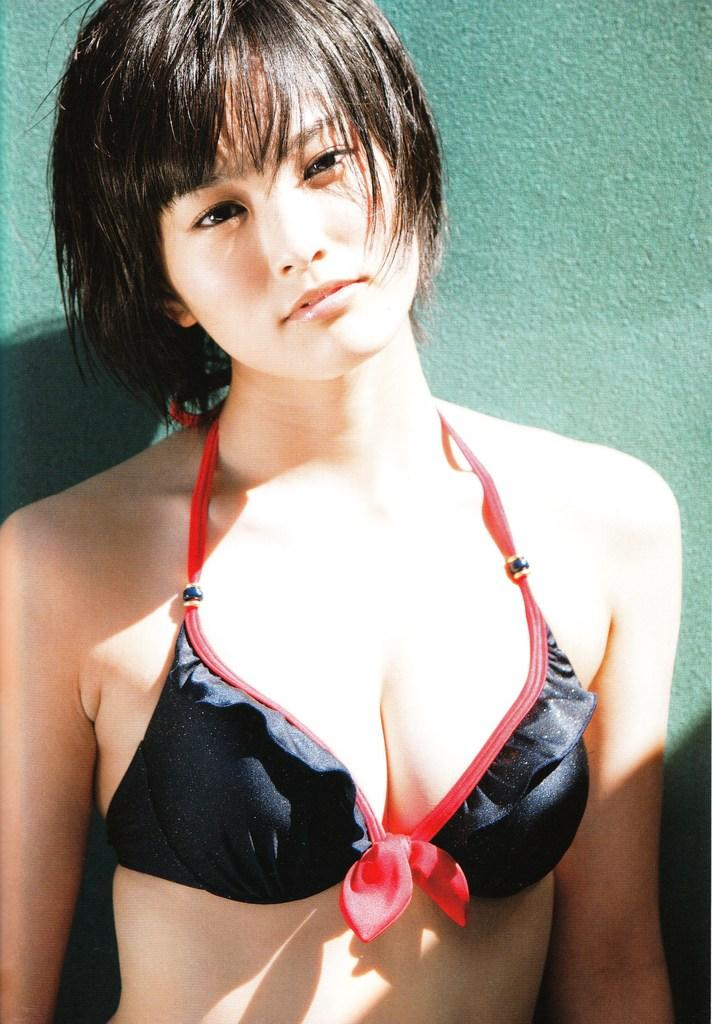Who is the main subject in the image? There is a woman in the image. What is the woman doing in the image? The woman is standing and posing for a photo. What can be seen in the background of the image? There is a wall in the background of the image. What is the color of the wall? The wall is green in color. What type of butter is being used to sing songs in the image? There is no butter or singing in the image; it features a woman standing and posing for a photo with a green wall in the background. 